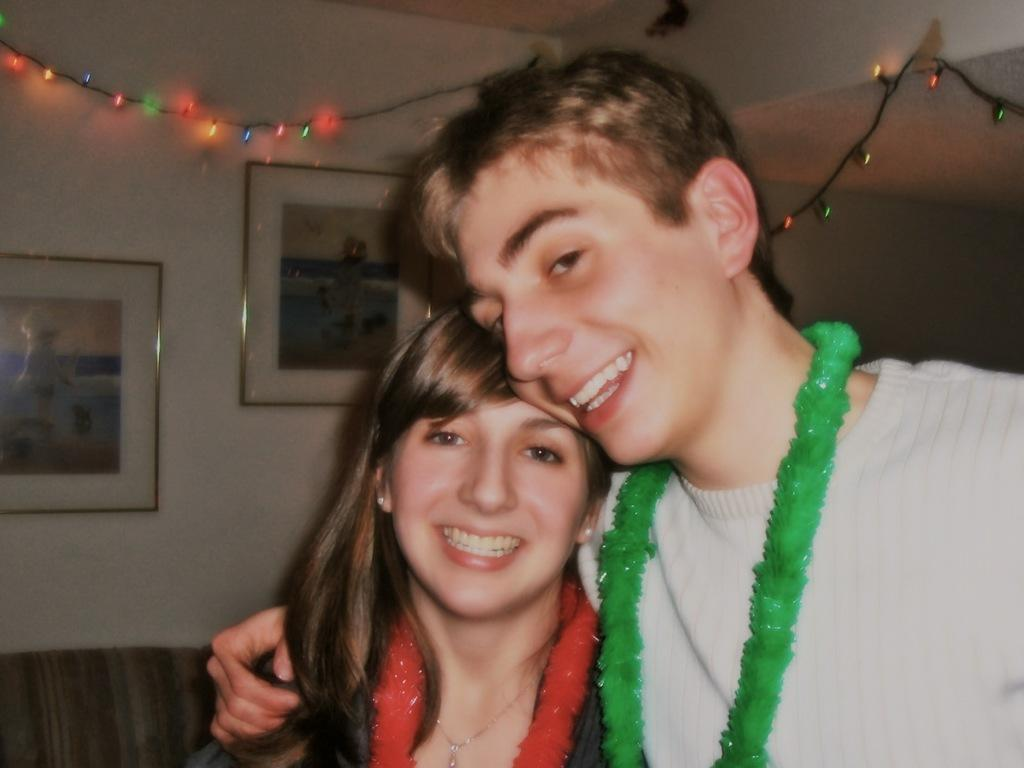How many people are present in the image? There is a man and a woman in the image. What can be seen in the background of the image? There are serial lights and a wall in the background of the image. What is hanging on the wall in the image? There are two photo frames on the wall. Can you describe the mountain visible in the image? There is no mountain present in the image. What type of art is displayed in the photo frames on the wall? The contents of the photo frames are not visible in the image, so we cannot determine the type of art displayed. 